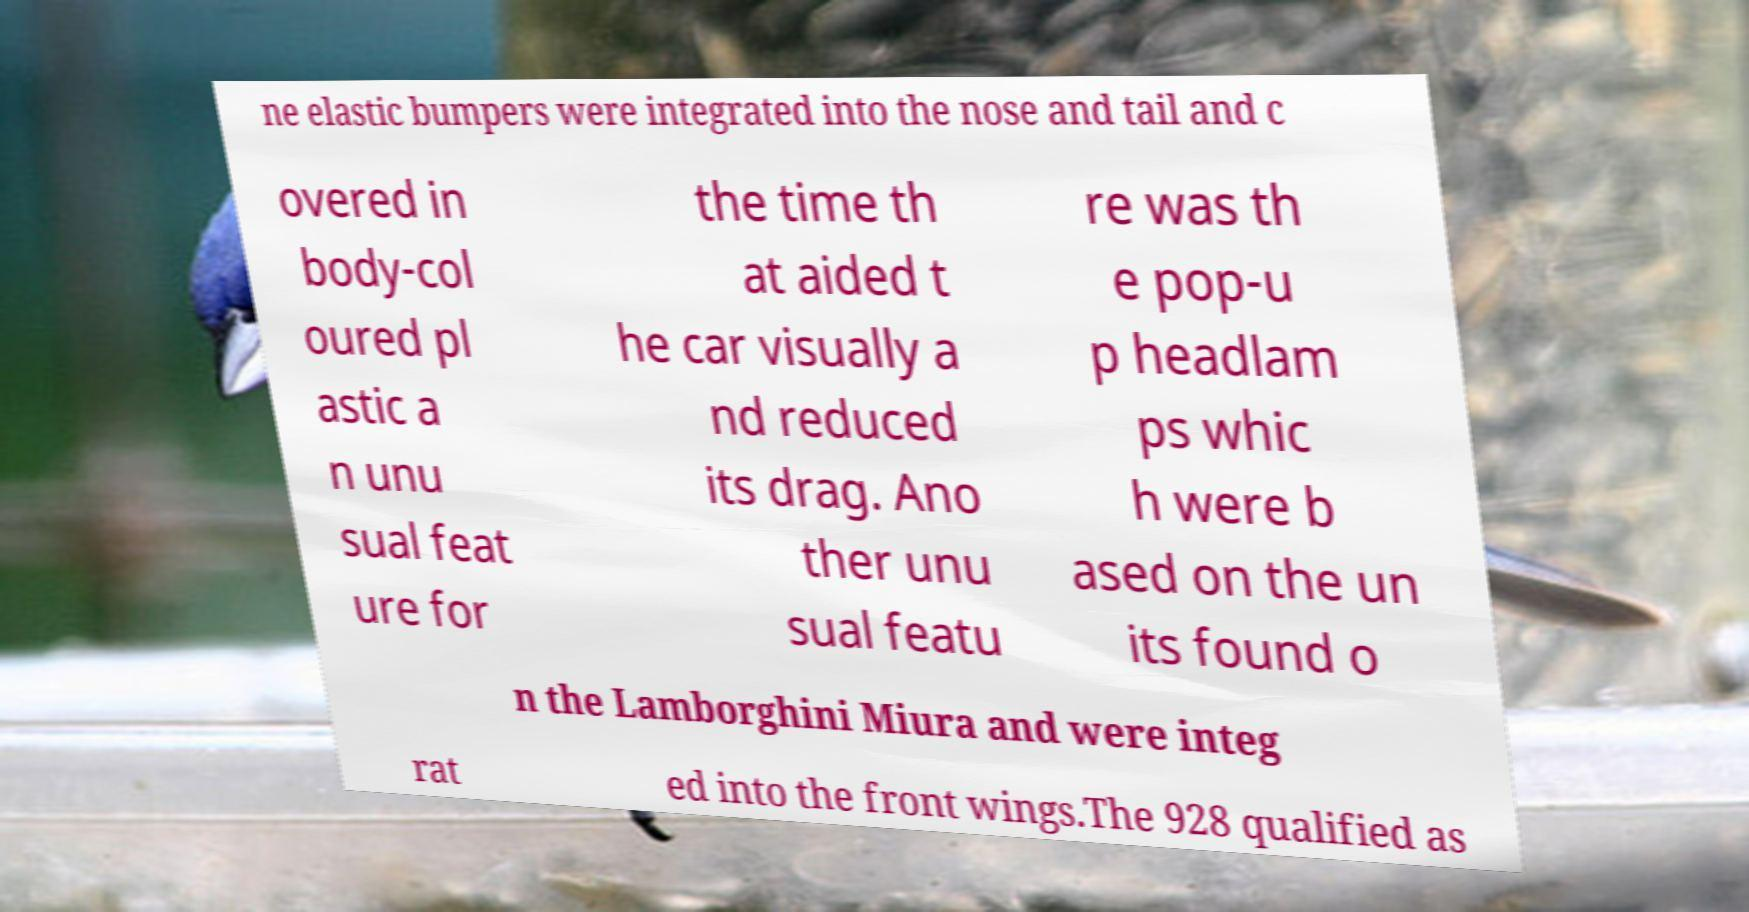Please read and relay the text visible in this image. What does it say? ne elastic bumpers were integrated into the nose and tail and c overed in body-col oured pl astic a n unu sual feat ure for the time th at aided t he car visually a nd reduced its drag. Ano ther unu sual featu re was th e pop-u p headlam ps whic h were b ased on the un its found o n the Lamborghini Miura and were integ rat ed into the front wings.The 928 qualified as 